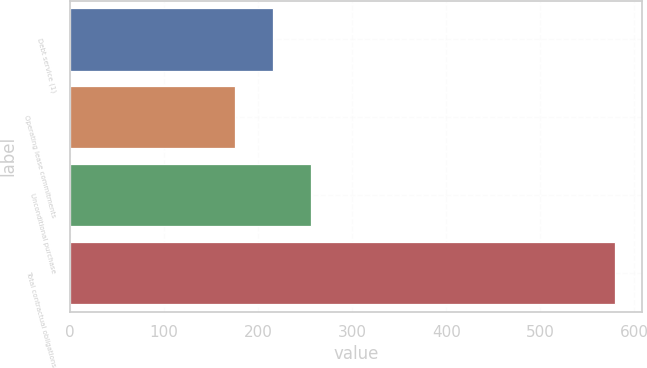Convert chart. <chart><loc_0><loc_0><loc_500><loc_500><bar_chart><fcel>Debt service (1)<fcel>Operating lease commitments<fcel>Unconditional purchase<fcel>Total contractual obligations<nl><fcel>216.03<fcel>175.7<fcel>256.36<fcel>579<nl></chart> 